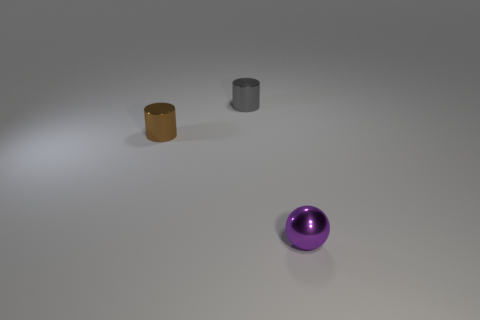What is the tiny object to the left of the small gray cylinder made of?
Your response must be concise. Metal. There is a small shiny thing in front of the small brown object; how many small brown shiny cylinders are on the right side of it?
Ensure brevity in your answer.  0. Are there any small red rubber objects that have the same shape as the gray shiny thing?
Provide a short and direct response. No. There is a metallic cylinder that is on the left side of the tiny gray metal thing; is it the same size as the metal object on the right side of the small gray shiny thing?
Your answer should be very brief. Yes. There is a object right of the shiny object that is behind the tiny brown cylinder; what is its shape?
Give a very brief answer. Sphere. What number of blue matte cylinders have the same size as the purple metal sphere?
Your answer should be compact. 0. Is there a rubber thing?
Provide a short and direct response. No. Are there any other things of the same color as the small metal ball?
Offer a terse response. No. What shape is the gray thing that is the same material as the purple ball?
Keep it short and to the point. Cylinder. What color is the small metallic object to the left of the small shiny cylinder behind the shiny cylinder that is in front of the gray cylinder?
Your response must be concise. Brown. 